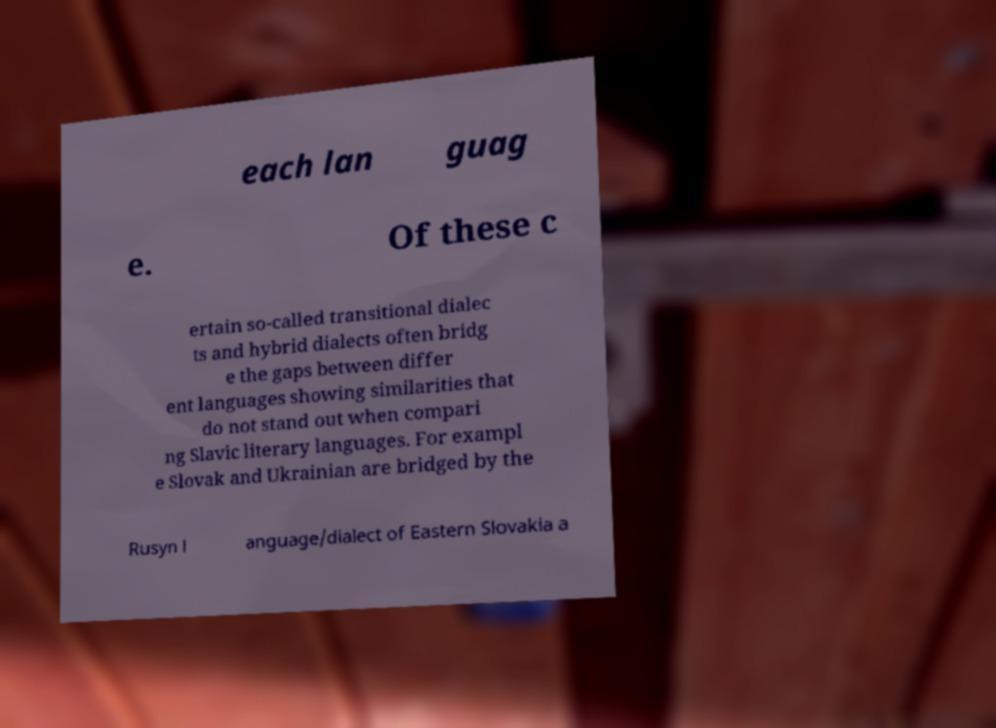Can you read and provide the text displayed in the image?This photo seems to have some interesting text. Can you extract and type it out for me? each lan guag e. Of these c ertain so-called transitional dialec ts and hybrid dialects often bridg e the gaps between differ ent languages showing similarities that do not stand out when compari ng Slavic literary languages. For exampl e Slovak and Ukrainian are bridged by the Rusyn l anguage/dialect of Eastern Slovakia a 